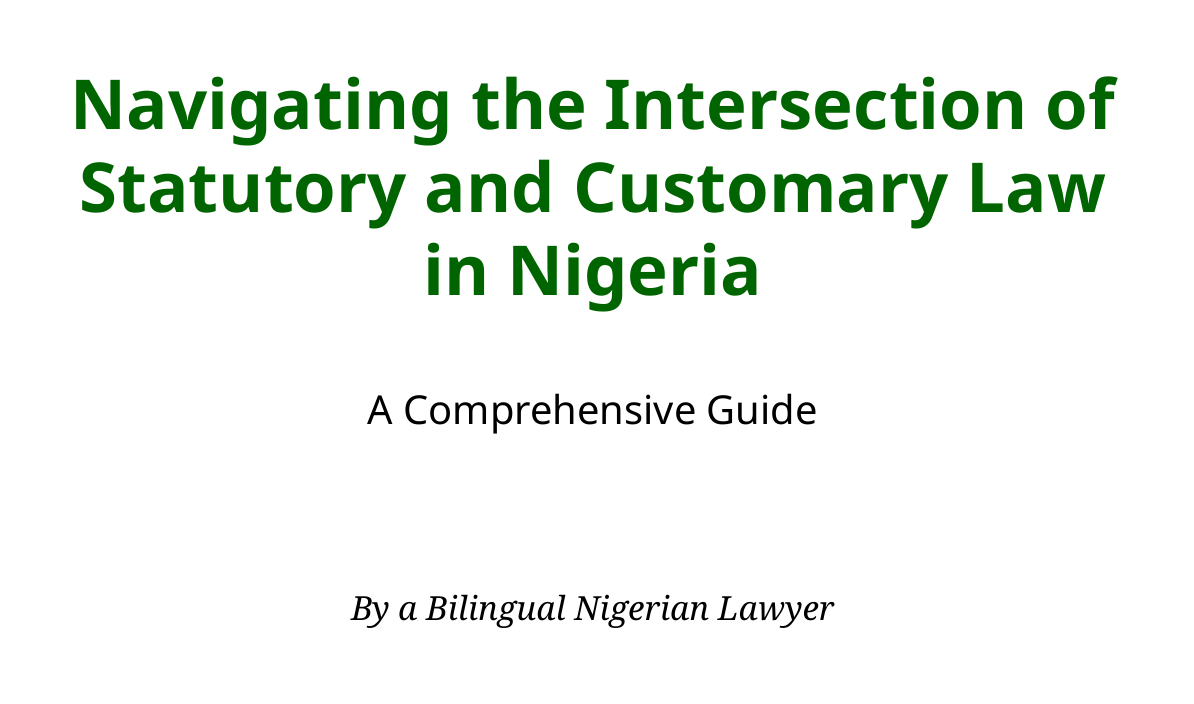What is the title of the guide? The title appears at the beginning of the document and presents the main topic addressed in the manual.
Answer: Navigating the Intersection of Statutory and Customary Law in Nigeria: A Comprehensive Guide Who is the author of the guide? The author is mentioned on the title page, providing insight into the qualifications of the writer.
Answer: A Bilingual Nigerian Lawyer What year was the case Ogunbambi v. Abowaba decided? The case is included in the Case Studies section which provides details about specific legal conflicts.
Answer: 1951 What is the outcome of the case Mojekwu v. Mojekwu? The outcome describes the court's decision regarding the validity of a specific custom related to inheritance.
Answer: Custom declared repugnant to natural justice, equity, and good conscience What constitutional section recognizes customary law? This refers to the specific legal provision that acknowledges the existence and validity of customary law in Nigeria.
Answer: Section 14 of the Evidence Act What does the guide emphasize regarding statutory and customary law? This concept is central to the document, addressing how statutory and customary law interact and the importance of understanding this dynamic.
Answer: Legal pluralism What is discussed in the section on Future Developments? This section involves initiatives focused on improving the relationship between different laws in Nigeria.
Answer: Law Reform Initiatives Which court handled the case Obiesie v. Obiesie? The court's name provides insight into the judicial system and its role in addressing matrimonial matters.
Answer: Supreme Court of Nigeria 